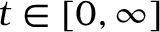Convert formula to latex. <formula><loc_0><loc_0><loc_500><loc_500>t \in [ 0 , \infty ]</formula> 